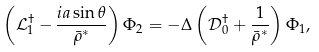<formula> <loc_0><loc_0><loc_500><loc_500>\left ( { \mathcal { L } ^ { \dag } _ { 1 } - \frac { i a \sin \theta } { \bar { \rho } ^ { * } } } \right ) \Phi _ { 2 } = - \Delta \left ( { \mathcal { D } ^ { \dag } _ { 0 } + \frac { 1 } { \bar { \rho } ^ { * } } } \right ) \Phi _ { 1 } ,</formula> 